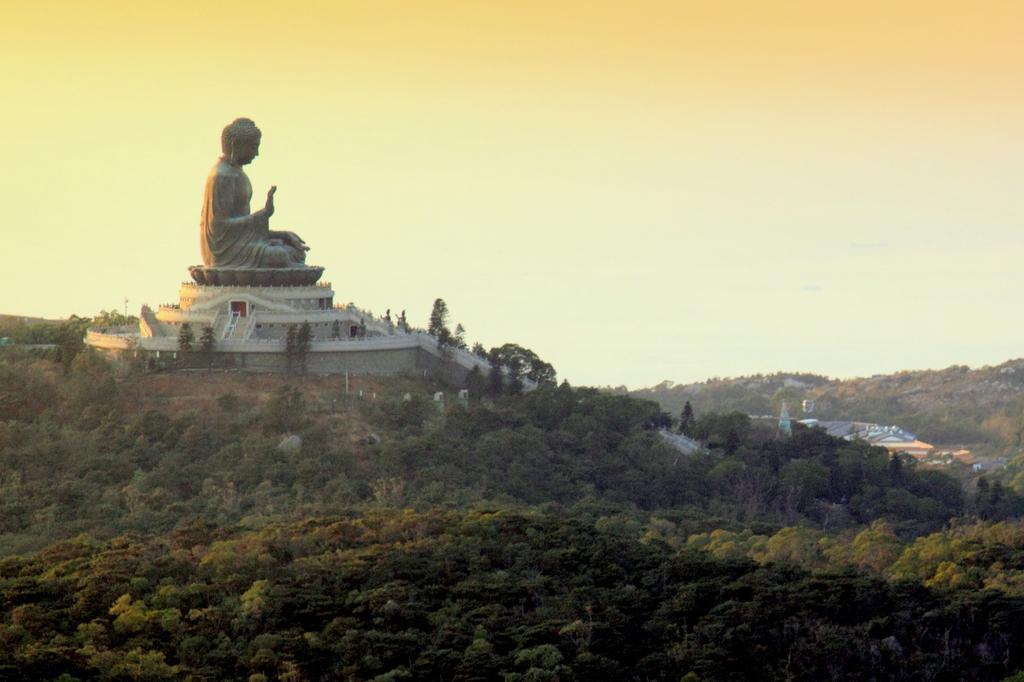Could you give a brief overview of what you see in this image? In this image we can see a statue, stairs and walls. In the foreground we can see a group of trees. Behind the trees we can see buildings and mountains. At the top we can see the sky. 